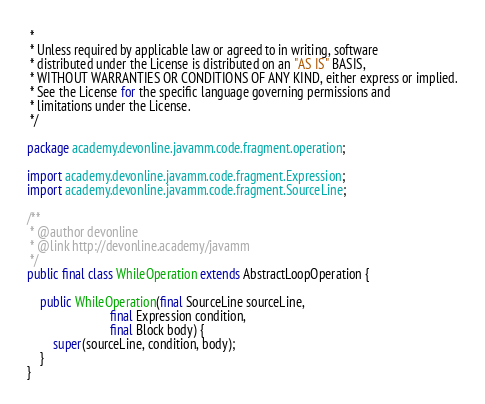Convert code to text. <code><loc_0><loc_0><loc_500><loc_500><_Java_> *
 * Unless required by applicable law or agreed to in writing, software
 * distributed under the License is distributed on an "AS IS" BASIS,
 * WITHOUT WARRANTIES OR CONDITIONS OF ANY KIND, either express or implied.
 * See the License for the specific language governing permissions and
 * limitations under the License.
 */

package academy.devonline.javamm.code.fragment.operation;

import academy.devonline.javamm.code.fragment.Expression;
import academy.devonline.javamm.code.fragment.SourceLine;

/**
 * @author devonline
 * @link http://devonline.academy/javamm
 */
public final class WhileOperation extends AbstractLoopOperation {

    public WhileOperation(final SourceLine sourceLine,
                          final Expression condition,
                          final Block body) {
        super(sourceLine, condition, body);
    }
}
</code> 